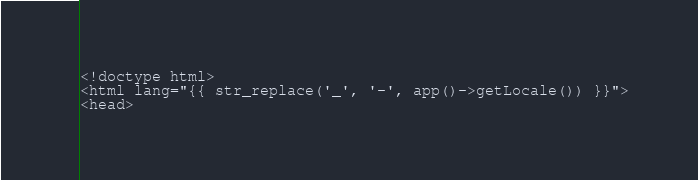Convert code to text. <code><loc_0><loc_0><loc_500><loc_500><_PHP_><!doctype html>
<html lang="{{ str_replace('_', '-', app()->getLocale()) }}">
<head></code> 